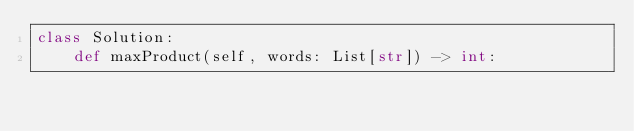Convert code to text. <code><loc_0><loc_0><loc_500><loc_500><_Python_>class Solution:
    def maxProduct(self, words: List[str]) -> int:
        
</code> 